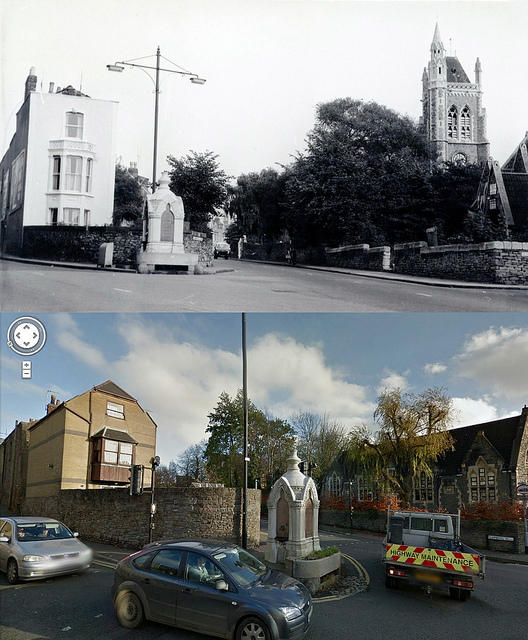<image>Why are the trees blurry? It is ambiguous why the trees are blurry. It could be due to poor camera focus or wind. Why are the trees blurry? I am not sure why the trees are blurry. It can be due to poor camera quality, wind, or lack of focus. 